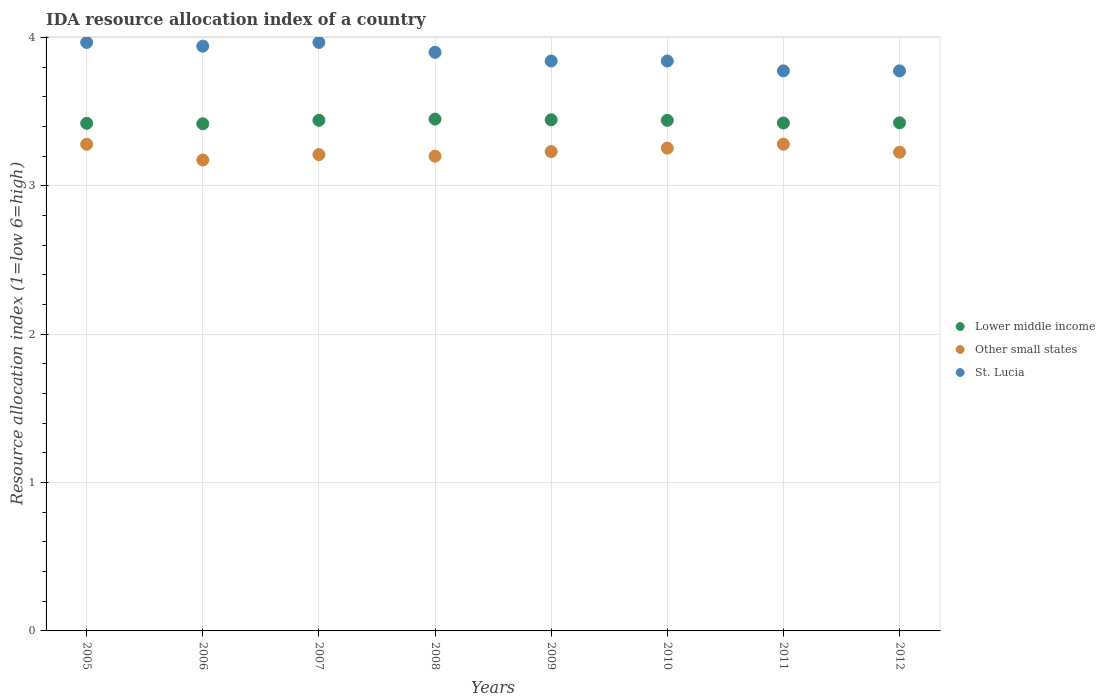Is the number of dotlines equal to the number of legend labels?
Make the answer very short. Yes. What is the IDA resource allocation index in Lower middle income in 2012?
Give a very brief answer. 3.42. Across all years, what is the maximum IDA resource allocation index in Lower middle income?
Offer a very short reply. 3.45. Across all years, what is the minimum IDA resource allocation index in Lower middle income?
Offer a very short reply. 3.42. What is the total IDA resource allocation index in Other small states in the graph?
Offer a terse response. 25.86. What is the difference between the IDA resource allocation index in Other small states in 2006 and that in 2011?
Your answer should be compact. -0.11. What is the difference between the IDA resource allocation index in St. Lucia in 2010 and the IDA resource allocation index in Lower middle income in 2009?
Offer a terse response. 0.4. What is the average IDA resource allocation index in Other small states per year?
Provide a succinct answer. 3.23. In the year 2008, what is the difference between the IDA resource allocation index in Lower middle income and IDA resource allocation index in St. Lucia?
Offer a very short reply. -0.45. What is the ratio of the IDA resource allocation index in St. Lucia in 2009 to that in 2011?
Your answer should be very brief. 1.02. Is the difference between the IDA resource allocation index in Lower middle income in 2009 and 2012 greater than the difference between the IDA resource allocation index in St. Lucia in 2009 and 2012?
Provide a succinct answer. No. What is the difference between the highest and the second highest IDA resource allocation index in Other small states?
Give a very brief answer. 0. What is the difference between the highest and the lowest IDA resource allocation index in Lower middle income?
Give a very brief answer. 0.03. Is the sum of the IDA resource allocation index in St. Lucia in 2005 and 2007 greater than the maximum IDA resource allocation index in Other small states across all years?
Provide a succinct answer. Yes. Is it the case that in every year, the sum of the IDA resource allocation index in St. Lucia and IDA resource allocation index in Other small states  is greater than the IDA resource allocation index in Lower middle income?
Give a very brief answer. Yes. Is the IDA resource allocation index in Other small states strictly greater than the IDA resource allocation index in Lower middle income over the years?
Your answer should be very brief. No. Is the IDA resource allocation index in Other small states strictly less than the IDA resource allocation index in Lower middle income over the years?
Your answer should be compact. Yes. How many dotlines are there?
Provide a succinct answer. 3. How many years are there in the graph?
Make the answer very short. 8. Are the values on the major ticks of Y-axis written in scientific E-notation?
Your answer should be very brief. No. Does the graph contain any zero values?
Your response must be concise. No. How many legend labels are there?
Give a very brief answer. 3. What is the title of the graph?
Your response must be concise. IDA resource allocation index of a country. What is the label or title of the Y-axis?
Make the answer very short. Resource allocation index (1=low 6=high). What is the Resource allocation index (1=low 6=high) in Lower middle income in 2005?
Ensure brevity in your answer.  3.42. What is the Resource allocation index (1=low 6=high) in Other small states in 2005?
Keep it short and to the point. 3.28. What is the Resource allocation index (1=low 6=high) of St. Lucia in 2005?
Offer a terse response. 3.97. What is the Resource allocation index (1=low 6=high) in Lower middle income in 2006?
Offer a terse response. 3.42. What is the Resource allocation index (1=low 6=high) of Other small states in 2006?
Give a very brief answer. 3.17. What is the Resource allocation index (1=low 6=high) in St. Lucia in 2006?
Make the answer very short. 3.94. What is the Resource allocation index (1=low 6=high) of Lower middle income in 2007?
Keep it short and to the point. 3.44. What is the Resource allocation index (1=low 6=high) in Other small states in 2007?
Provide a succinct answer. 3.21. What is the Resource allocation index (1=low 6=high) in St. Lucia in 2007?
Ensure brevity in your answer.  3.97. What is the Resource allocation index (1=low 6=high) of Lower middle income in 2008?
Offer a very short reply. 3.45. What is the Resource allocation index (1=low 6=high) of St. Lucia in 2008?
Keep it short and to the point. 3.9. What is the Resource allocation index (1=low 6=high) in Lower middle income in 2009?
Provide a short and direct response. 3.45. What is the Resource allocation index (1=low 6=high) in Other small states in 2009?
Keep it short and to the point. 3.23. What is the Resource allocation index (1=low 6=high) in St. Lucia in 2009?
Ensure brevity in your answer.  3.84. What is the Resource allocation index (1=low 6=high) of Lower middle income in 2010?
Your response must be concise. 3.44. What is the Resource allocation index (1=low 6=high) of Other small states in 2010?
Offer a terse response. 3.25. What is the Resource allocation index (1=low 6=high) of St. Lucia in 2010?
Give a very brief answer. 3.84. What is the Resource allocation index (1=low 6=high) of Lower middle income in 2011?
Your response must be concise. 3.42. What is the Resource allocation index (1=low 6=high) in Other small states in 2011?
Give a very brief answer. 3.28. What is the Resource allocation index (1=low 6=high) in St. Lucia in 2011?
Your answer should be compact. 3.77. What is the Resource allocation index (1=low 6=high) of Lower middle income in 2012?
Make the answer very short. 3.42. What is the Resource allocation index (1=low 6=high) of Other small states in 2012?
Make the answer very short. 3.23. What is the Resource allocation index (1=low 6=high) of St. Lucia in 2012?
Make the answer very short. 3.77. Across all years, what is the maximum Resource allocation index (1=low 6=high) in Lower middle income?
Provide a succinct answer. 3.45. Across all years, what is the maximum Resource allocation index (1=low 6=high) of Other small states?
Provide a succinct answer. 3.28. Across all years, what is the maximum Resource allocation index (1=low 6=high) in St. Lucia?
Offer a very short reply. 3.97. Across all years, what is the minimum Resource allocation index (1=low 6=high) in Lower middle income?
Offer a terse response. 3.42. Across all years, what is the minimum Resource allocation index (1=low 6=high) of Other small states?
Your answer should be compact. 3.17. Across all years, what is the minimum Resource allocation index (1=low 6=high) of St. Lucia?
Your response must be concise. 3.77. What is the total Resource allocation index (1=low 6=high) of Lower middle income in the graph?
Ensure brevity in your answer.  27.47. What is the total Resource allocation index (1=low 6=high) in Other small states in the graph?
Make the answer very short. 25.86. What is the total Resource allocation index (1=low 6=high) of St. Lucia in the graph?
Make the answer very short. 31.01. What is the difference between the Resource allocation index (1=low 6=high) of Lower middle income in 2005 and that in 2006?
Offer a terse response. 0. What is the difference between the Resource allocation index (1=low 6=high) in Other small states in 2005 and that in 2006?
Provide a short and direct response. 0.11. What is the difference between the Resource allocation index (1=low 6=high) of St. Lucia in 2005 and that in 2006?
Provide a succinct answer. 0.03. What is the difference between the Resource allocation index (1=low 6=high) of Lower middle income in 2005 and that in 2007?
Your answer should be compact. -0.02. What is the difference between the Resource allocation index (1=low 6=high) of Other small states in 2005 and that in 2007?
Your answer should be compact. 0.07. What is the difference between the Resource allocation index (1=low 6=high) in Lower middle income in 2005 and that in 2008?
Provide a succinct answer. -0.03. What is the difference between the Resource allocation index (1=low 6=high) of Other small states in 2005 and that in 2008?
Provide a succinct answer. 0.08. What is the difference between the Resource allocation index (1=low 6=high) in St. Lucia in 2005 and that in 2008?
Your answer should be compact. 0.07. What is the difference between the Resource allocation index (1=low 6=high) of Lower middle income in 2005 and that in 2009?
Ensure brevity in your answer.  -0.02. What is the difference between the Resource allocation index (1=low 6=high) in Other small states in 2005 and that in 2009?
Make the answer very short. 0.05. What is the difference between the Resource allocation index (1=low 6=high) in Lower middle income in 2005 and that in 2010?
Give a very brief answer. -0.02. What is the difference between the Resource allocation index (1=low 6=high) in Other small states in 2005 and that in 2010?
Offer a terse response. 0.03. What is the difference between the Resource allocation index (1=low 6=high) of St. Lucia in 2005 and that in 2010?
Your response must be concise. 0.12. What is the difference between the Resource allocation index (1=low 6=high) of Lower middle income in 2005 and that in 2011?
Make the answer very short. -0. What is the difference between the Resource allocation index (1=low 6=high) in Other small states in 2005 and that in 2011?
Keep it short and to the point. -0. What is the difference between the Resource allocation index (1=low 6=high) in St. Lucia in 2005 and that in 2011?
Keep it short and to the point. 0.19. What is the difference between the Resource allocation index (1=low 6=high) in Lower middle income in 2005 and that in 2012?
Keep it short and to the point. -0. What is the difference between the Resource allocation index (1=low 6=high) of Other small states in 2005 and that in 2012?
Keep it short and to the point. 0.05. What is the difference between the Resource allocation index (1=low 6=high) in St. Lucia in 2005 and that in 2012?
Your response must be concise. 0.19. What is the difference between the Resource allocation index (1=low 6=high) of Lower middle income in 2006 and that in 2007?
Your answer should be very brief. -0.02. What is the difference between the Resource allocation index (1=low 6=high) in Other small states in 2006 and that in 2007?
Provide a short and direct response. -0.04. What is the difference between the Resource allocation index (1=low 6=high) in St. Lucia in 2006 and that in 2007?
Offer a terse response. -0.03. What is the difference between the Resource allocation index (1=low 6=high) in Lower middle income in 2006 and that in 2008?
Offer a terse response. -0.03. What is the difference between the Resource allocation index (1=low 6=high) in Other small states in 2006 and that in 2008?
Your response must be concise. -0.03. What is the difference between the Resource allocation index (1=low 6=high) in St. Lucia in 2006 and that in 2008?
Offer a very short reply. 0.04. What is the difference between the Resource allocation index (1=low 6=high) in Lower middle income in 2006 and that in 2009?
Ensure brevity in your answer.  -0.03. What is the difference between the Resource allocation index (1=low 6=high) in Other small states in 2006 and that in 2009?
Provide a succinct answer. -0.06. What is the difference between the Resource allocation index (1=low 6=high) of St. Lucia in 2006 and that in 2009?
Give a very brief answer. 0.1. What is the difference between the Resource allocation index (1=low 6=high) in Lower middle income in 2006 and that in 2010?
Ensure brevity in your answer.  -0.02. What is the difference between the Resource allocation index (1=low 6=high) of Other small states in 2006 and that in 2010?
Provide a succinct answer. -0.08. What is the difference between the Resource allocation index (1=low 6=high) in St. Lucia in 2006 and that in 2010?
Your response must be concise. 0.1. What is the difference between the Resource allocation index (1=low 6=high) of Lower middle income in 2006 and that in 2011?
Your response must be concise. -0.01. What is the difference between the Resource allocation index (1=low 6=high) in Other small states in 2006 and that in 2011?
Your answer should be very brief. -0.11. What is the difference between the Resource allocation index (1=low 6=high) of St. Lucia in 2006 and that in 2011?
Give a very brief answer. 0.17. What is the difference between the Resource allocation index (1=low 6=high) of Lower middle income in 2006 and that in 2012?
Keep it short and to the point. -0.01. What is the difference between the Resource allocation index (1=low 6=high) of Other small states in 2006 and that in 2012?
Your response must be concise. -0.05. What is the difference between the Resource allocation index (1=low 6=high) of St. Lucia in 2006 and that in 2012?
Provide a short and direct response. 0.17. What is the difference between the Resource allocation index (1=low 6=high) of Lower middle income in 2007 and that in 2008?
Your response must be concise. -0.01. What is the difference between the Resource allocation index (1=low 6=high) in Other small states in 2007 and that in 2008?
Keep it short and to the point. 0.01. What is the difference between the Resource allocation index (1=low 6=high) of St. Lucia in 2007 and that in 2008?
Give a very brief answer. 0.07. What is the difference between the Resource allocation index (1=low 6=high) in Lower middle income in 2007 and that in 2009?
Provide a succinct answer. -0. What is the difference between the Resource allocation index (1=low 6=high) in Other small states in 2007 and that in 2009?
Provide a short and direct response. -0.02. What is the difference between the Resource allocation index (1=low 6=high) in Lower middle income in 2007 and that in 2010?
Your answer should be very brief. 0. What is the difference between the Resource allocation index (1=low 6=high) of Other small states in 2007 and that in 2010?
Provide a short and direct response. -0.04. What is the difference between the Resource allocation index (1=low 6=high) of St. Lucia in 2007 and that in 2010?
Your answer should be very brief. 0.12. What is the difference between the Resource allocation index (1=low 6=high) in Lower middle income in 2007 and that in 2011?
Offer a terse response. 0.02. What is the difference between the Resource allocation index (1=low 6=high) of Other small states in 2007 and that in 2011?
Keep it short and to the point. -0.07. What is the difference between the Resource allocation index (1=low 6=high) in St. Lucia in 2007 and that in 2011?
Your answer should be very brief. 0.19. What is the difference between the Resource allocation index (1=low 6=high) of Lower middle income in 2007 and that in 2012?
Provide a succinct answer. 0.02. What is the difference between the Resource allocation index (1=low 6=high) in Other small states in 2007 and that in 2012?
Your answer should be compact. -0.02. What is the difference between the Resource allocation index (1=low 6=high) in St. Lucia in 2007 and that in 2012?
Offer a terse response. 0.19. What is the difference between the Resource allocation index (1=low 6=high) in Lower middle income in 2008 and that in 2009?
Make the answer very short. 0. What is the difference between the Resource allocation index (1=low 6=high) in Other small states in 2008 and that in 2009?
Ensure brevity in your answer.  -0.03. What is the difference between the Resource allocation index (1=low 6=high) of St. Lucia in 2008 and that in 2009?
Make the answer very short. 0.06. What is the difference between the Resource allocation index (1=low 6=high) in Lower middle income in 2008 and that in 2010?
Ensure brevity in your answer.  0.01. What is the difference between the Resource allocation index (1=low 6=high) in Other small states in 2008 and that in 2010?
Keep it short and to the point. -0.05. What is the difference between the Resource allocation index (1=low 6=high) in St. Lucia in 2008 and that in 2010?
Your response must be concise. 0.06. What is the difference between the Resource allocation index (1=low 6=high) in Lower middle income in 2008 and that in 2011?
Ensure brevity in your answer.  0.03. What is the difference between the Resource allocation index (1=low 6=high) in Other small states in 2008 and that in 2011?
Make the answer very short. -0.08. What is the difference between the Resource allocation index (1=low 6=high) in Lower middle income in 2008 and that in 2012?
Provide a short and direct response. 0.03. What is the difference between the Resource allocation index (1=low 6=high) of Other small states in 2008 and that in 2012?
Provide a short and direct response. -0.03. What is the difference between the Resource allocation index (1=low 6=high) of Lower middle income in 2009 and that in 2010?
Offer a very short reply. 0. What is the difference between the Resource allocation index (1=low 6=high) of Other small states in 2009 and that in 2010?
Provide a short and direct response. -0.02. What is the difference between the Resource allocation index (1=low 6=high) in St. Lucia in 2009 and that in 2010?
Your response must be concise. 0. What is the difference between the Resource allocation index (1=low 6=high) of Lower middle income in 2009 and that in 2011?
Provide a short and direct response. 0.02. What is the difference between the Resource allocation index (1=low 6=high) in Other small states in 2009 and that in 2011?
Your response must be concise. -0.05. What is the difference between the Resource allocation index (1=low 6=high) of St. Lucia in 2009 and that in 2011?
Your answer should be very brief. 0.07. What is the difference between the Resource allocation index (1=low 6=high) in Lower middle income in 2009 and that in 2012?
Offer a very short reply. 0.02. What is the difference between the Resource allocation index (1=low 6=high) of Other small states in 2009 and that in 2012?
Your response must be concise. 0. What is the difference between the Resource allocation index (1=low 6=high) of St. Lucia in 2009 and that in 2012?
Provide a short and direct response. 0.07. What is the difference between the Resource allocation index (1=low 6=high) of Lower middle income in 2010 and that in 2011?
Make the answer very short. 0.02. What is the difference between the Resource allocation index (1=low 6=high) of Other small states in 2010 and that in 2011?
Provide a short and direct response. -0.03. What is the difference between the Resource allocation index (1=low 6=high) in St. Lucia in 2010 and that in 2011?
Provide a succinct answer. 0.07. What is the difference between the Resource allocation index (1=low 6=high) of Lower middle income in 2010 and that in 2012?
Offer a very short reply. 0.02. What is the difference between the Resource allocation index (1=low 6=high) in Other small states in 2010 and that in 2012?
Your answer should be very brief. 0.03. What is the difference between the Resource allocation index (1=low 6=high) in St. Lucia in 2010 and that in 2012?
Your response must be concise. 0.07. What is the difference between the Resource allocation index (1=low 6=high) of Lower middle income in 2011 and that in 2012?
Your response must be concise. -0. What is the difference between the Resource allocation index (1=low 6=high) of Other small states in 2011 and that in 2012?
Your response must be concise. 0.05. What is the difference between the Resource allocation index (1=low 6=high) in Lower middle income in 2005 and the Resource allocation index (1=low 6=high) in Other small states in 2006?
Ensure brevity in your answer.  0.25. What is the difference between the Resource allocation index (1=low 6=high) of Lower middle income in 2005 and the Resource allocation index (1=low 6=high) of St. Lucia in 2006?
Provide a succinct answer. -0.52. What is the difference between the Resource allocation index (1=low 6=high) of Other small states in 2005 and the Resource allocation index (1=low 6=high) of St. Lucia in 2006?
Provide a succinct answer. -0.66. What is the difference between the Resource allocation index (1=low 6=high) in Lower middle income in 2005 and the Resource allocation index (1=low 6=high) in Other small states in 2007?
Provide a succinct answer. 0.21. What is the difference between the Resource allocation index (1=low 6=high) in Lower middle income in 2005 and the Resource allocation index (1=low 6=high) in St. Lucia in 2007?
Provide a succinct answer. -0.55. What is the difference between the Resource allocation index (1=low 6=high) in Other small states in 2005 and the Resource allocation index (1=low 6=high) in St. Lucia in 2007?
Make the answer very short. -0.69. What is the difference between the Resource allocation index (1=low 6=high) in Lower middle income in 2005 and the Resource allocation index (1=low 6=high) in Other small states in 2008?
Offer a terse response. 0.22. What is the difference between the Resource allocation index (1=low 6=high) of Lower middle income in 2005 and the Resource allocation index (1=low 6=high) of St. Lucia in 2008?
Give a very brief answer. -0.48. What is the difference between the Resource allocation index (1=low 6=high) of Other small states in 2005 and the Resource allocation index (1=low 6=high) of St. Lucia in 2008?
Make the answer very short. -0.62. What is the difference between the Resource allocation index (1=low 6=high) in Lower middle income in 2005 and the Resource allocation index (1=low 6=high) in Other small states in 2009?
Ensure brevity in your answer.  0.19. What is the difference between the Resource allocation index (1=low 6=high) of Lower middle income in 2005 and the Resource allocation index (1=low 6=high) of St. Lucia in 2009?
Keep it short and to the point. -0.42. What is the difference between the Resource allocation index (1=low 6=high) of Other small states in 2005 and the Resource allocation index (1=low 6=high) of St. Lucia in 2009?
Your response must be concise. -0.56. What is the difference between the Resource allocation index (1=low 6=high) in Lower middle income in 2005 and the Resource allocation index (1=low 6=high) in Other small states in 2010?
Offer a terse response. 0.17. What is the difference between the Resource allocation index (1=low 6=high) of Lower middle income in 2005 and the Resource allocation index (1=low 6=high) of St. Lucia in 2010?
Offer a terse response. -0.42. What is the difference between the Resource allocation index (1=low 6=high) in Other small states in 2005 and the Resource allocation index (1=low 6=high) in St. Lucia in 2010?
Ensure brevity in your answer.  -0.56. What is the difference between the Resource allocation index (1=low 6=high) of Lower middle income in 2005 and the Resource allocation index (1=low 6=high) of Other small states in 2011?
Your answer should be compact. 0.14. What is the difference between the Resource allocation index (1=low 6=high) of Lower middle income in 2005 and the Resource allocation index (1=low 6=high) of St. Lucia in 2011?
Offer a very short reply. -0.35. What is the difference between the Resource allocation index (1=low 6=high) in Other small states in 2005 and the Resource allocation index (1=low 6=high) in St. Lucia in 2011?
Make the answer very short. -0.49. What is the difference between the Resource allocation index (1=low 6=high) in Lower middle income in 2005 and the Resource allocation index (1=low 6=high) in Other small states in 2012?
Provide a short and direct response. 0.2. What is the difference between the Resource allocation index (1=low 6=high) of Lower middle income in 2005 and the Resource allocation index (1=low 6=high) of St. Lucia in 2012?
Your answer should be compact. -0.35. What is the difference between the Resource allocation index (1=low 6=high) of Other small states in 2005 and the Resource allocation index (1=low 6=high) of St. Lucia in 2012?
Ensure brevity in your answer.  -0.49. What is the difference between the Resource allocation index (1=low 6=high) of Lower middle income in 2006 and the Resource allocation index (1=low 6=high) of Other small states in 2007?
Your answer should be compact. 0.21. What is the difference between the Resource allocation index (1=low 6=high) in Lower middle income in 2006 and the Resource allocation index (1=low 6=high) in St. Lucia in 2007?
Offer a terse response. -0.55. What is the difference between the Resource allocation index (1=low 6=high) of Other small states in 2006 and the Resource allocation index (1=low 6=high) of St. Lucia in 2007?
Your answer should be very brief. -0.79. What is the difference between the Resource allocation index (1=low 6=high) in Lower middle income in 2006 and the Resource allocation index (1=low 6=high) in Other small states in 2008?
Your answer should be very brief. 0.22. What is the difference between the Resource allocation index (1=low 6=high) in Lower middle income in 2006 and the Resource allocation index (1=low 6=high) in St. Lucia in 2008?
Offer a very short reply. -0.48. What is the difference between the Resource allocation index (1=low 6=high) of Other small states in 2006 and the Resource allocation index (1=low 6=high) of St. Lucia in 2008?
Offer a terse response. -0.73. What is the difference between the Resource allocation index (1=low 6=high) in Lower middle income in 2006 and the Resource allocation index (1=low 6=high) in Other small states in 2009?
Keep it short and to the point. 0.19. What is the difference between the Resource allocation index (1=low 6=high) of Lower middle income in 2006 and the Resource allocation index (1=low 6=high) of St. Lucia in 2009?
Ensure brevity in your answer.  -0.42. What is the difference between the Resource allocation index (1=low 6=high) in Other small states in 2006 and the Resource allocation index (1=low 6=high) in St. Lucia in 2009?
Offer a terse response. -0.67. What is the difference between the Resource allocation index (1=low 6=high) of Lower middle income in 2006 and the Resource allocation index (1=low 6=high) of Other small states in 2010?
Your answer should be compact. 0.16. What is the difference between the Resource allocation index (1=low 6=high) in Lower middle income in 2006 and the Resource allocation index (1=low 6=high) in St. Lucia in 2010?
Offer a very short reply. -0.42. What is the difference between the Resource allocation index (1=low 6=high) in Other small states in 2006 and the Resource allocation index (1=low 6=high) in St. Lucia in 2010?
Offer a very short reply. -0.67. What is the difference between the Resource allocation index (1=low 6=high) in Lower middle income in 2006 and the Resource allocation index (1=low 6=high) in Other small states in 2011?
Give a very brief answer. 0.14. What is the difference between the Resource allocation index (1=low 6=high) of Lower middle income in 2006 and the Resource allocation index (1=low 6=high) of St. Lucia in 2011?
Your answer should be very brief. -0.36. What is the difference between the Resource allocation index (1=low 6=high) of Other small states in 2006 and the Resource allocation index (1=low 6=high) of St. Lucia in 2011?
Ensure brevity in your answer.  -0.6. What is the difference between the Resource allocation index (1=low 6=high) in Lower middle income in 2006 and the Resource allocation index (1=low 6=high) in Other small states in 2012?
Your answer should be compact. 0.19. What is the difference between the Resource allocation index (1=low 6=high) of Lower middle income in 2006 and the Resource allocation index (1=low 6=high) of St. Lucia in 2012?
Make the answer very short. -0.36. What is the difference between the Resource allocation index (1=low 6=high) of Other small states in 2006 and the Resource allocation index (1=low 6=high) of St. Lucia in 2012?
Offer a very short reply. -0.6. What is the difference between the Resource allocation index (1=low 6=high) of Lower middle income in 2007 and the Resource allocation index (1=low 6=high) of Other small states in 2008?
Provide a short and direct response. 0.24. What is the difference between the Resource allocation index (1=low 6=high) in Lower middle income in 2007 and the Resource allocation index (1=low 6=high) in St. Lucia in 2008?
Your answer should be very brief. -0.46. What is the difference between the Resource allocation index (1=low 6=high) in Other small states in 2007 and the Resource allocation index (1=low 6=high) in St. Lucia in 2008?
Offer a very short reply. -0.69. What is the difference between the Resource allocation index (1=low 6=high) in Lower middle income in 2007 and the Resource allocation index (1=low 6=high) in Other small states in 2009?
Ensure brevity in your answer.  0.21. What is the difference between the Resource allocation index (1=low 6=high) of Lower middle income in 2007 and the Resource allocation index (1=low 6=high) of St. Lucia in 2009?
Your response must be concise. -0.4. What is the difference between the Resource allocation index (1=low 6=high) in Other small states in 2007 and the Resource allocation index (1=low 6=high) in St. Lucia in 2009?
Offer a terse response. -0.63. What is the difference between the Resource allocation index (1=low 6=high) in Lower middle income in 2007 and the Resource allocation index (1=low 6=high) in Other small states in 2010?
Your answer should be very brief. 0.19. What is the difference between the Resource allocation index (1=low 6=high) in Lower middle income in 2007 and the Resource allocation index (1=low 6=high) in St. Lucia in 2010?
Keep it short and to the point. -0.4. What is the difference between the Resource allocation index (1=low 6=high) of Other small states in 2007 and the Resource allocation index (1=low 6=high) of St. Lucia in 2010?
Your answer should be compact. -0.63. What is the difference between the Resource allocation index (1=low 6=high) in Lower middle income in 2007 and the Resource allocation index (1=low 6=high) in Other small states in 2011?
Offer a terse response. 0.16. What is the difference between the Resource allocation index (1=low 6=high) in Lower middle income in 2007 and the Resource allocation index (1=low 6=high) in St. Lucia in 2011?
Your answer should be compact. -0.33. What is the difference between the Resource allocation index (1=low 6=high) in Other small states in 2007 and the Resource allocation index (1=low 6=high) in St. Lucia in 2011?
Your response must be concise. -0.56. What is the difference between the Resource allocation index (1=low 6=high) in Lower middle income in 2007 and the Resource allocation index (1=low 6=high) in Other small states in 2012?
Keep it short and to the point. 0.22. What is the difference between the Resource allocation index (1=low 6=high) of Lower middle income in 2007 and the Resource allocation index (1=low 6=high) of St. Lucia in 2012?
Your response must be concise. -0.33. What is the difference between the Resource allocation index (1=low 6=high) of Other small states in 2007 and the Resource allocation index (1=low 6=high) of St. Lucia in 2012?
Give a very brief answer. -0.56. What is the difference between the Resource allocation index (1=low 6=high) in Lower middle income in 2008 and the Resource allocation index (1=low 6=high) in Other small states in 2009?
Provide a short and direct response. 0.22. What is the difference between the Resource allocation index (1=low 6=high) of Lower middle income in 2008 and the Resource allocation index (1=low 6=high) of St. Lucia in 2009?
Make the answer very short. -0.39. What is the difference between the Resource allocation index (1=low 6=high) of Other small states in 2008 and the Resource allocation index (1=low 6=high) of St. Lucia in 2009?
Keep it short and to the point. -0.64. What is the difference between the Resource allocation index (1=low 6=high) of Lower middle income in 2008 and the Resource allocation index (1=low 6=high) of Other small states in 2010?
Your answer should be very brief. 0.2. What is the difference between the Resource allocation index (1=low 6=high) in Lower middle income in 2008 and the Resource allocation index (1=low 6=high) in St. Lucia in 2010?
Your response must be concise. -0.39. What is the difference between the Resource allocation index (1=low 6=high) of Other small states in 2008 and the Resource allocation index (1=low 6=high) of St. Lucia in 2010?
Give a very brief answer. -0.64. What is the difference between the Resource allocation index (1=low 6=high) in Lower middle income in 2008 and the Resource allocation index (1=low 6=high) in Other small states in 2011?
Keep it short and to the point. 0.17. What is the difference between the Resource allocation index (1=low 6=high) of Lower middle income in 2008 and the Resource allocation index (1=low 6=high) of St. Lucia in 2011?
Provide a short and direct response. -0.33. What is the difference between the Resource allocation index (1=low 6=high) in Other small states in 2008 and the Resource allocation index (1=low 6=high) in St. Lucia in 2011?
Ensure brevity in your answer.  -0.57. What is the difference between the Resource allocation index (1=low 6=high) in Lower middle income in 2008 and the Resource allocation index (1=low 6=high) in Other small states in 2012?
Offer a very short reply. 0.22. What is the difference between the Resource allocation index (1=low 6=high) in Lower middle income in 2008 and the Resource allocation index (1=low 6=high) in St. Lucia in 2012?
Provide a succinct answer. -0.33. What is the difference between the Resource allocation index (1=low 6=high) of Other small states in 2008 and the Resource allocation index (1=low 6=high) of St. Lucia in 2012?
Keep it short and to the point. -0.57. What is the difference between the Resource allocation index (1=low 6=high) of Lower middle income in 2009 and the Resource allocation index (1=low 6=high) of Other small states in 2010?
Your answer should be compact. 0.19. What is the difference between the Resource allocation index (1=low 6=high) of Lower middle income in 2009 and the Resource allocation index (1=low 6=high) of St. Lucia in 2010?
Your answer should be compact. -0.4. What is the difference between the Resource allocation index (1=low 6=high) in Other small states in 2009 and the Resource allocation index (1=low 6=high) in St. Lucia in 2010?
Offer a very short reply. -0.61. What is the difference between the Resource allocation index (1=low 6=high) in Lower middle income in 2009 and the Resource allocation index (1=low 6=high) in Other small states in 2011?
Make the answer very short. 0.16. What is the difference between the Resource allocation index (1=low 6=high) of Lower middle income in 2009 and the Resource allocation index (1=low 6=high) of St. Lucia in 2011?
Your answer should be compact. -0.33. What is the difference between the Resource allocation index (1=low 6=high) of Other small states in 2009 and the Resource allocation index (1=low 6=high) of St. Lucia in 2011?
Provide a short and direct response. -0.54. What is the difference between the Resource allocation index (1=low 6=high) in Lower middle income in 2009 and the Resource allocation index (1=low 6=high) in Other small states in 2012?
Provide a short and direct response. 0.22. What is the difference between the Resource allocation index (1=low 6=high) in Lower middle income in 2009 and the Resource allocation index (1=low 6=high) in St. Lucia in 2012?
Your answer should be very brief. -0.33. What is the difference between the Resource allocation index (1=low 6=high) in Other small states in 2009 and the Resource allocation index (1=low 6=high) in St. Lucia in 2012?
Make the answer very short. -0.54. What is the difference between the Resource allocation index (1=low 6=high) in Lower middle income in 2010 and the Resource allocation index (1=low 6=high) in Other small states in 2011?
Make the answer very short. 0.16. What is the difference between the Resource allocation index (1=low 6=high) in Lower middle income in 2010 and the Resource allocation index (1=low 6=high) in St. Lucia in 2011?
Keep it short and to the point. -0.33. What is the difference between the Resource allocation index (1=low 6=high) of Other small states in 2010 and the Resource allocation index (1=low 6=high) of St. Lucia in 2011?
Offer a very short reply. -0.52. What is the difference between the Resource allocation index (1=low 6=high) in Lower middle income in 2010 and the Resource allocation index (1=low 6=high) in Other small states in 2012?
Give a very brief answer. 0.21. What is the difference between the Resource allocation index (1=low 6=high) of Lower middle income in 2010 and the Resource allocation index (1=low 6=high) of St. Lucia in 2012?
Ensure brevity in your answer.  -0.33. What is the difference between the Resource allocation index (1=low 6=high) of Other small states in 2010 and the Resource allocation index (1=low 6=high) of St. Lucia in 2012?
Make the answer very short. -0.52. What is the difference between the Resource allocation index (1=low 6=high) in Lower middle income in 2011 and the Resource allocation index (1=low 6=high) in Other small states in 2012?
Provide a succinct answer. 0.2. What is the difference between the Resource allocation index (1=low 6=high) of Lower middle income in 2011 and the Resource allocation index (1=low 6=high) of St. Lucia in 2012?
Make the answer very short. -0.35. What is the difference between the Resource allocation index (1=low 6=high) in Other small states in 2011 and the Resource allocation index (1=low 6=high) in St. Lucia in 2012?
Your answer should be very brief. -0.49. What is the average Resource allocation index (1=low 6=high) in Lower middle income per year?
Offer a terse response. 3.43. What is the average Resource allocation index (1=low 6=high) in Other small states per year?
Your answer should be very brief. 3.23. What is the average Resource allocation index (1=low 6=high) in St. Lucia per year?
Your response must be concise. 3.88. In the year 2005, what is the difference between the Resource allocation index (1=low 6=high) in Lower middle income and Resource allocation index (1=low 6=high) in Other small states?
Give a very brief answer. 0.14. In the year 2005, what is the difference between the Resource allocation index (1=low 6=high) in Lower middle income and Resource allocation index (1=low 6=high) in St. Lucia?
Your answer should be compact. -0.55. In the year 2005, what is the difference between the Resource allocation index (1=low 6=high) of Other small states and Resource allocation index (1=low 6=high) of St. Lucia?
Offer a terse response. -0.69. In the year 2006, what is the difference between the Resource allocation index (1=low 6=high) in Lower middle income and Resource allocation index (1=low 6=high) in Other small states?
Your answer should be compact. 0.24. In the year 2006, what is the difference between the Resource allocation index (1=low 6=high) of Lower middle income and Resource allocation index (1=low 6=high) of St. Lucia?
Your answer should be very brief. -0.52. In the year 2006, what is the difference between the Resource allocation index (1=low 6=high) of Other small states and Resource allocation index (1=low 6=high) of St. Lucia?
Give a very brief answer. -0.77. In the year 2007, what is the difference between the Resource allocation index (1=low 6=high) in Lower middle income and Resource allocation index (1=low 6=high) in Other small states?
Provide a succinct answer. 0.23. In the year 2007, what is the difference between the Resource allocation index (1=low 6=high) of Lower middle income and Resource allocation index (1=low 6=high) of St. Lucia?
Offer a very short reply. -0.52. In the year 2007, what is the difference between the Resource allocation index (1=low 6=high) in Other small states and Resource allocation index (1=low 6=high) in St. Lucia?
Your response must be concise. -0.76. In the year 2008, what is the difference between the Resource allocation index (1=low 6=high) in Lower middle income and Resource allocation index (1=low 6=high) in St. Lucia?
Offer a very short reply. -0.45. In the year 2008, what is the difference between the Resource allocation index (1=low 6=high) in Other small states and Resource allocation index (1=low 6=high) in St. Lucia?
Offer a very short reply. -0.7. In the year 2009, what is the difference between the Resource allocation index (1=low 6=high) in Lower middle income and Resource allocation index (1=low 6=high) in Other small states?
Your answer should be compact. 0.21. In the year 2009, what is the difference between the Resource allocation index (1=low 6=high) of Lower middle income and Resource allocation index (1=low 6=high) of St. Lucia?
Provide a short and direct response. -0.4. In the year 2009, what is the difference between the Resource allocation index (1=low 6=high) in Other small states and Resource allocation index (1=low 6=high) in St. Lucia?
Provide a short and direct response. -0.61. In the year 2010, what is the difference between the Resource allocation index (1=low 6=high) in Lower middle income and Resource allocation index (1=low 6=high) in Other small states?
Your response must be concise. 0.19. In the year 2010, what is the difference between the Resource allocation index (1=low 6=high) of Lower middle income and Resource allocation index (1=low 6=high) of St. Lucia?
Your answer should be compact. -0.4. In the year 2010, what is the difference between the Resource allocation index (1=low 6=high) in Other small states and Resource allocation index (1=low 6=high) in St. Lucia?
Your response must be concise. -0.59. In the year 2011, what is the difference between the Resource allocation index (1=low 6=high) of Lower middle income and Resource allocation index (1=low 6=high) of Other small states?
Offer a very short reply. 0.14. In the year 2011, what is the difference between the Resource allocation index (1=low 6=high) of Lower middle income and Resource allocation index (1=low 6=high) of St. Lucia?
Offer a very short reply. -0.35. In the year 2011, what is the difference between the Resource allocation index (1=low 6=high) in Other small states and Resource allocation index (1=low 6=high) in St. Lucia?
Keep it short and to the point. -0.49. In the year 2012, what is the difference between the Resource allocation index (1=low 6=high) of Lower middle income and Resource allocation index (1=low 6=high) of Other small states?
Your response must be concise. 0.2. In the year 2012, what is the difference between the Resource allocation index (1=low 6=high) in Lower middle income and Resource allocation index (1=low 6=high) in St. Lucia?
Provide a succinct answer. -0.35. In the year 2012, what is the difference between the Resource allocation index (1=low 6=high) of Other small states and Resource allocation index (1=low 6=high) of St. Lucia?
Offer a very short reply. -0.55. What is the ratio of the Resource allocation index (1=low 6=high) of Other small states in 2005 to that in 2006?
Keep it short and to the point. 1.03. What is the ratio of the Resource allocation index (1=low 6=high) in Other small states in 2005 to that in 2007?
Offer a very short reply. 1.02. What is the ratio of the Resource allocation index (1=low 6=high) of St. Lucia in 2005 to that in 2007?
Your answer should be very brief. 1. What is the ratio of the Resource allocation index (1=low 6=high) in Lower middle income in 2005 to that in 2008?
Provide a succinct answer. 0.99. What is the ratio of the Resource allocation index (1=low 6=high) in Other small states in 2005 to that in 2008?
Provide a succinct answer. 1.03. What is the ratio of the Resource allocation index (1=low 6=high) in St. Lucia in 2005 to that in 2008?
Provide a short and direct response. 1.02. What is the ratio of the Resource allocation index (1=low 6=high) of Other small states in 2005 to that in 2009?
Your answer should be very brief. 1.02. What is the ratio of the Resource allocation index (1=low 6=high) of St. Lucia in 2005 to that in 2009?
Your answer should be very brief. 1.03. What is the ratio of the Resource allocation index (1=low 6=high) in Lower middle income in 2005 to that in 2010?
Offer a very short reply. 0.99. What is the ratio of the Resource allocation index (1=low 6=high) in St. Lucia in 2005 to that in 2010?
Your answer should be compact. 1.03. What is the ratio of the Resource allocation index (1=low 6=high) in Lower middle income in 2005 to that in 2011?
Keep it short and to the point. 1. What is the ratio of the Resource allocation index (1=low 6=high) of St. Lucia in 2005 to that in 2011?
Your response must be concise. 1.05. What is the ratio of the Resource allocation index (1=low 6=high) in Lower middle income in 2005 to that in 2012?
Ensure brevity in your answer.  1. What is the ratio of the Resource allocation index (1=low 6=high) in Other small states in 2005 to that in 2012?
Provide a succinct answer. 1.02. What is the ratio of the Resource allocation index (1=low 6=high) in St. Lucia in 2005 to that in 2012?
Offer a very short reply. 1.05. What is the ratio of the Resource allocation index (1=low 6=high) of Lower middle income in 2006 to that in 2007?
Provide a short and direct response. 0.99. What is the ratio of the Resource allocation index (1=low 6=high) in Other small states in 2006 to that in 2007?
Keep it short and to the point. 0.99. What is the ratio of the Resource allocation index (1=low 6=high) in St. Lucia in 2006 to that in 2007?
Your answer should be very brief. 0.99. What is the ratio of the Resource allocation index (1=low 6=high) of Lower middle income in 2006 to that in 2008?
Give a very brief answer. 0.99. What is the ratio of the Resource allocation index (1=low 6=high) of St. Lucia in 2006 to that in 2008?
Your response must be concise. 1.01. What is the ratio of the Resource allocation index (1=low 6=high) in Other small states in 2006 to that in 2009?
Ensure brevity in your answer.  0.98. What is the ratio of the Resource allocation index (1=low 6=high) of Other small states in 2006 to that in 2010?
Offer a very short reply. 0.98. What is the ratio of the Resource allocation index (1=low 6=high) in St. Lucia in 2006 to that in 2010?
Ensure brevity in your answer.  1.03. What is the ratio of the Resource allocation index (1=low 6=high) of Lower middle income in 2006 to that in 2011?
Ensure brevity in your answer.  1. What is the ratio of the Resource allocation index (1=low 6=high) in Other small states in 2006 to that in 2011?
Offer a very short reply. 0.97. What is the ratio of the Resource allocation index (1=low 6=high) in St. Lucia in 2006 to that in 2011?
Your response must be concise. 1.04. What is the ratio of the Resource allocation index (1=low 6=high) in Lower middle income in 2006 to that in 2012?
Your answer should be compact. 1. What is the ratio of the Resource allocation index (1=low 6=high) of Other small states in 2006 to that in 2012?
Provide a succinct answer. 0.98. What is the ratio of the Resource allocation index (1=low 6=high) in St. Lucia in 2006 to that in 2012?
Your answer should be compact. 1.04. What is the ratio of the Resource allocation index (1=low 6=high) in Lower middle income in 2007 to that in 2008?
Your response must be concise. 1. What is the ratio of the Resource allocation index (1=low 6=high) in Other small states in 2007 to that in 2008?
Your answer should be very brief. 1. What is the ratio of the Resource allocation index (1=low 6=high) of St. Lucia in 2007 to that in 2008?
Make the answer very short. 1.02. What is the ratio of the Resource allocation index (1=low 6=high) of Other small states in 2007 to that in 2009?
Your answer should be very brief. 0.99. What is the ratio of the Resource allocation index (1=low 6=high) in St. Lucia in 2007 to that in 2009?
Keep it short and to the point. 1.03. What is the ratio of the Resource allocation index (1=low 6=high) of Other small states in 2007 to that in 2010?
Keep it short and to the point. 0.99. What is the ratio of the Resource allocation index (1=low 6=high) of St. Lucia in 2007 to that in 2010?
Your response must be concise. 1.03. What is the ratio of the Resource allocation index (1=low 6=high) of Other small states in 2007 to that in 2011?
Make the answer very short. 0.98. What is the ratio of the Resource allocation index (1=low 6=high) of St. Lucia in 2007 to that in 2011?
Your answer should be compact. 1.05. What is the ratio of the Resource allocation index (1=low 6=high) of Lower middle income in 2007 to that in 2012?
Provide a short and direct response. 1. What is the ratio of the Resource allocation index (1=low 6=high) in Other small states in 2007 to that in 2012?
Ensure brevity in your answer.  1. What is the ratio of the Resource allocation index (1=low 6=high) in St. Lucia in 2007 to that in 2012?
Provide a short and direct response. 1.05. What is the ratio of the Resource allocation index (1=low 6=high) in Lower middle income in 2008 to that in 2009?
Your response must be concise. 1. What is the ratio of the Resource allocation index (1=low 6=high) in St. Lucia in 2008 to that in 2009?
Your answer should be compact. 1.02. What is the ratio of the Resource allocation index (1=low 6=high) in Other small states in 2008 to that in 2010?
Provide a short and direct response. 0.98. What is the ratio of the Resource allocation index (1=low 6=high) of St. Lucia in 2008 to that in 2010?
Provide a succinct answer. 1.02. What is the ratio of the Resource allocation index (1=low 6=high) in Lower middle income in 2008 to that in 2011?
Give a very brief answer. 1.01. What is the ratio of the Resource allocation index (1=low 6=high) in Other small states in 2008 to that in 2011?
Ensure brevity in your answer.  0.98. What is the ratio of the Resource allocation index (1=low 6=high) of St. Lucia in 2008 to that in 2011?
Offer a very short reply. 1.03. What is the ratio of the Resource allocation index (1=low 6=high) of Lower middle income in 2008 to that in 2012?
Offer a very short reply. 1.01. What is the ratio of the Resource allocation index (1=low 6=high) in Other small states in 2008 to that in 2012?
Make the answer very short. 0.99. What is the ratio of the Resource allocation index (1=low 6=high) of St. Lucia in 2008 to that in 2012?
Make the answer very short. 1.03. What is the ratio of the Resource allocation index (1=low 6=high) of Other small states in 2009 to that in 2010?
Offer a very short reply. 0.99. What is the ratio of the Resource allocation index (1=low 6=high) in St. Lucia in 2009 to that in 2010?
Your answer should be very brief. 1. What is the ratio of the Resource allocation index (1=low 6=high) of Lower middle income in 2009 to that in 2011?
Make the answer very short. 1.01. What is the ratio of the Resource allocation index (1=low 6=high) in St. Lucia in 2009 to that in 2011?
Your response must be concise. 1.02. What is the ratio of the Resource allocation index (1=low 6=high) of Lower middle income in 2009 to that in 2012?
Provide a short and direct response. 1.01. What is the ratio of the Resource allocation index (1=low 6=high) of Other small states in 2009 to that in 2012?
Your response must be concise. 1. What is the ratio of the Resource allocation index (1=low 6=high) of St. Lucia in 2009 to that in 2012?
Offer a terse response. 1.02. What is the ratio of the Resource allocation index (1=low 6=high) in Lower middle income in 2010 to that in 2011?
Your response must be concise. 1.01. What is the ratio of the Resource allocation index (1=low 6=high) in St. Lucia in 2010 to that in 2011?
Give a very brief answer. 1.02. What is the ratio of the Resource allocation index (1=low 6=high) of Lower middle income in 2010 to that in 2012?
Provide a short and direct response. 1. What is the ratio of the Resource allocation index (1=low 6=high) of Other small states in 2010 to that in 2012?
Your answer should be compact. 1.01. What is the ratio of the Resource allocation index (1=low 6=high) of St. Lucia in 2010 to that in 2012?
Your response must be concise. 1.02. What is the ratio of the Resource allocation index (1=low 6=high) of Other small states in 2011 to that in 2012?
Make the answer very short. 1.02. What is the ratio of the Resource allocation index (1=low 6=high) of St. Lucia in 2011 to that in 2012?
Your answer should be compact. 1. What is the difference between the highest and the second highest Resource allocation index (1=low 6=high) in Lower middle income?
Make the answer very short. 0. What is the difference between the highest and the lowest Resource allocation index (1=low 6=high) of Lower middle income?
Offer a terse response. 0.03. What is the difference between the highest and the lowest Resource allocation index (1=low 6=high) of Other small states?
Ensure brevity in your answer.  0.11. What is the difference between the highest and the lowest Resource allocation index (1=low 6=high) of St. Lucia?
Provide a short and direct response. 0.19. 